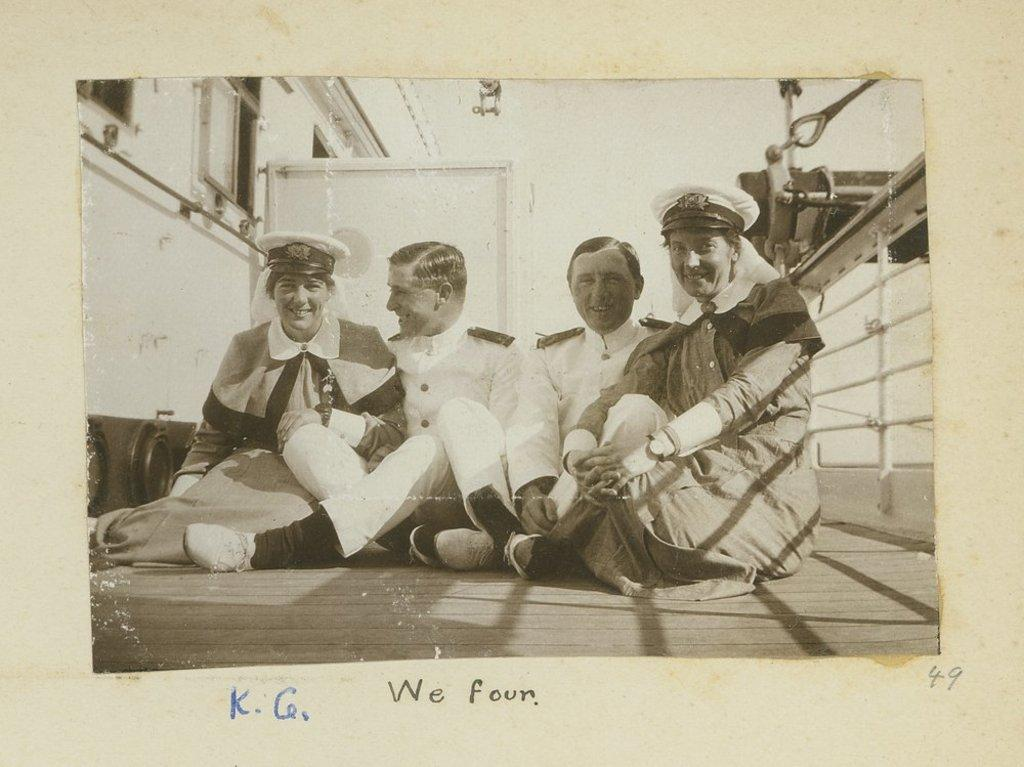How many people are sitting on the floor in the image? There are four people sitting on the floor in the image. What can be observed about the person in front? The person in front is wearing a uniform. What can be seen in the background of the image? There is a wall visible in the background of the image. What is the color scheme of the image? The image is in black and white. What type of clouds can be seen in the image? There are no clouds visible in the image, as it is in black and white and does not depict an outdoor scene. 